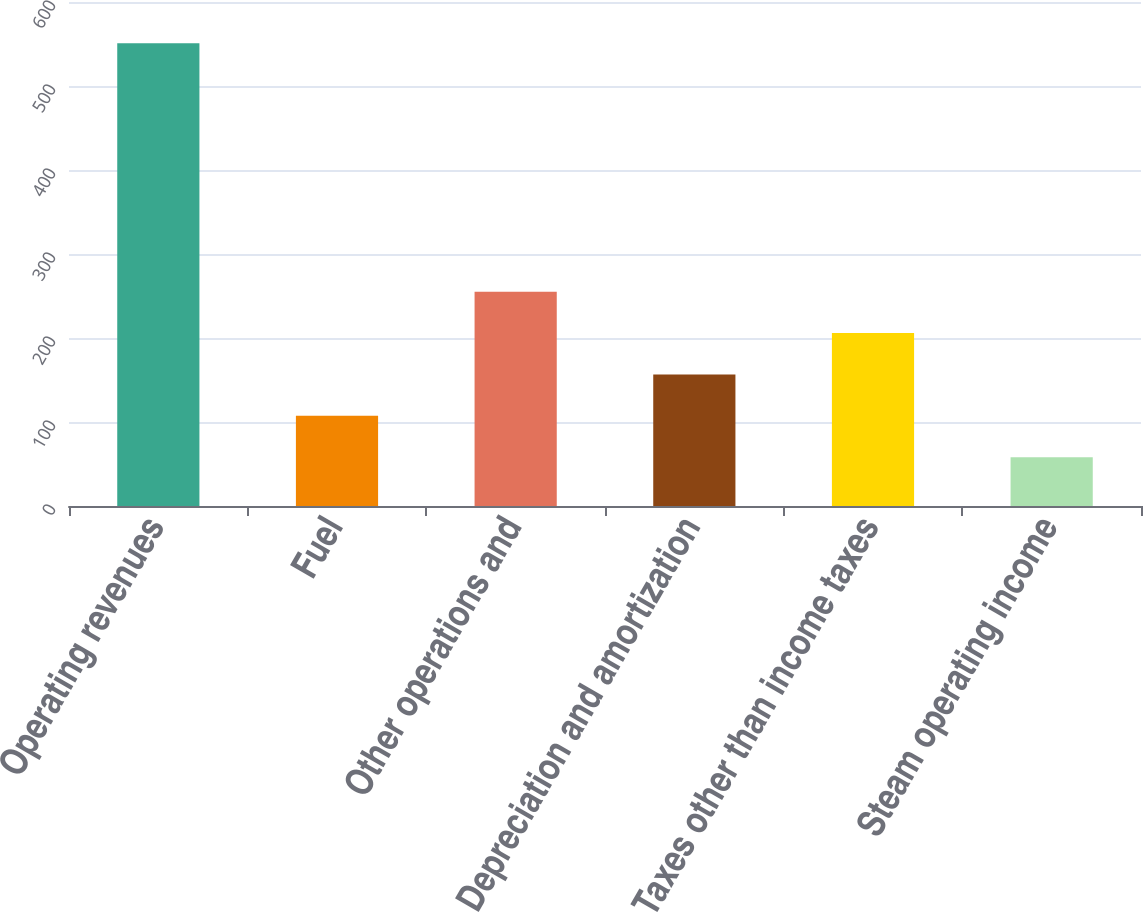Convert chart to OTSL. <chart><loc_0><loc_0><loc_500><loc_500><bar_chart><fcel>Operating revenues<fcel>Fuel<fcel>Other operations and<fcel>Depreciation and amortization<fcel>Taxes other than income taxes<fcel>Steam operating income<nl><fcel>551<fcel>107.3<fcel>255.2<fcel>156.6<fcel>205.9<fcel>58<nl></chart> 